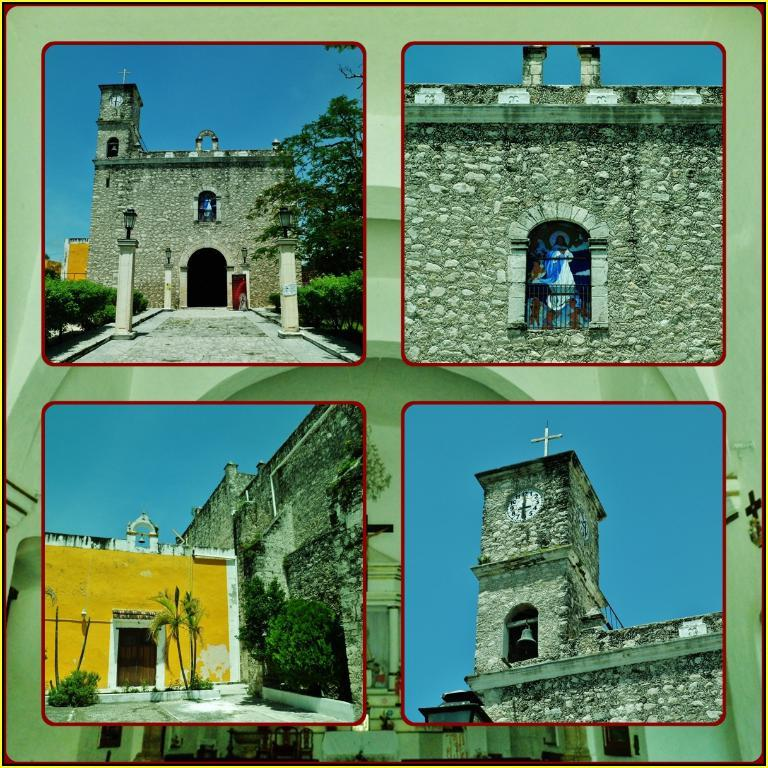What type of artwork is the image? The image is a collage. What religious structure can be seen in the image? There is a holy church in the image. What type of objects are present in the image? There are statues, trees, lights, a clock, and a bell in the image. What part of the natural environment is visible in the image? Trees and the sky are visible in the image. What time-related object is present in the image? There is a clock in the image. What type of plate is being used to destroy the church in the image? There is no plate or destruction present in the image; it features a collage of a holy church, statues, trees, lights, a clock, and a bell. What source of power is being used to operate the bell in the image? The image does not provide information about the source of power for the bell; it only shows the bell as part of the collage. 